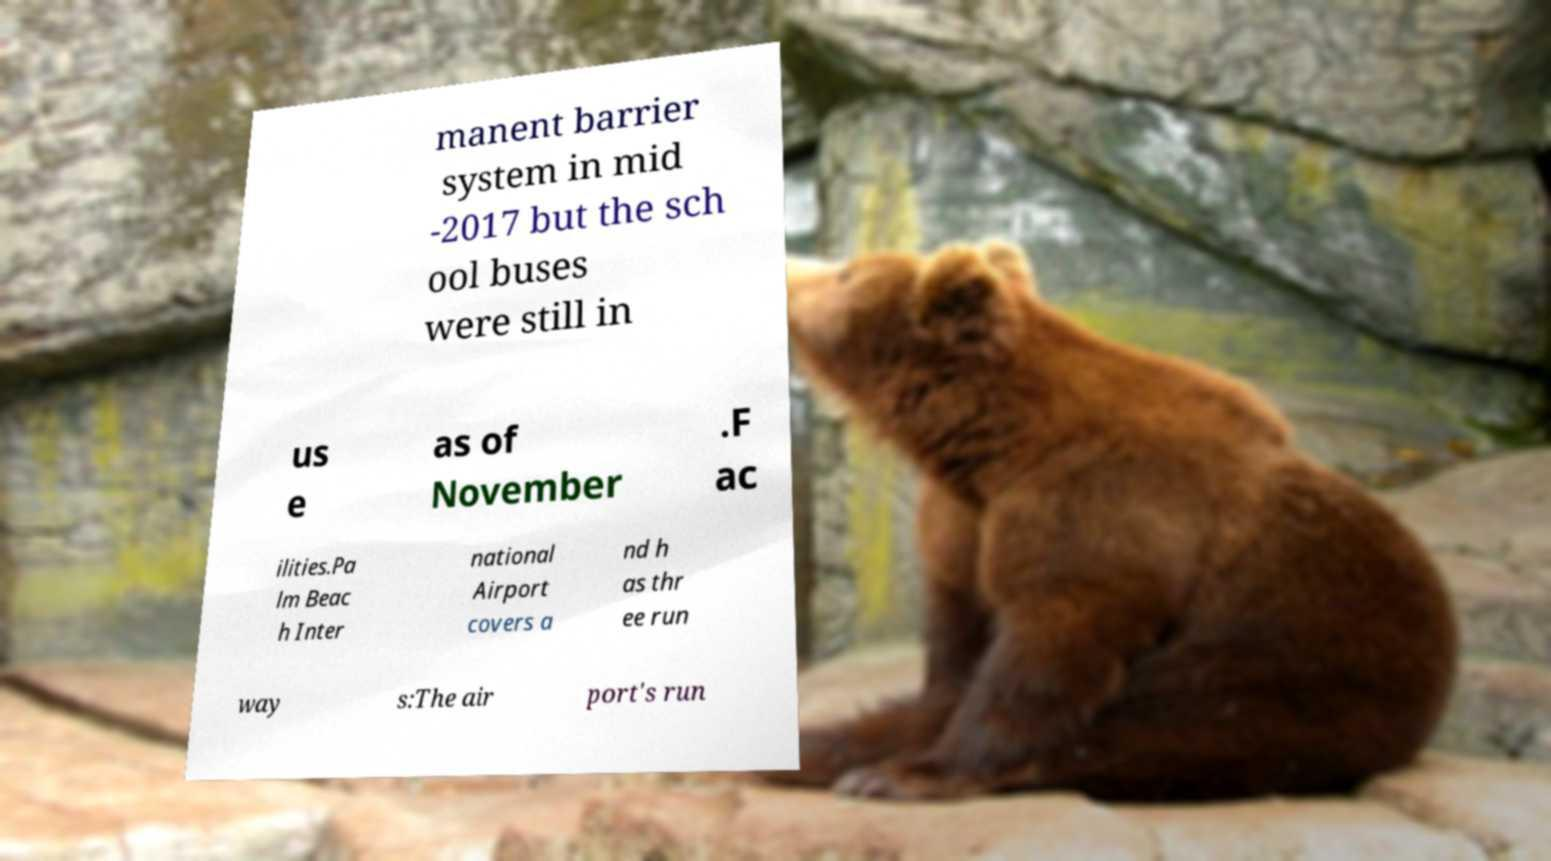Please identify and transcribe the text found in this image. manent barrier system in mid -2017 but the sch ool buses were still in us e as of November .F ac ilities.Pa lm Beac h Inter national Airport covers a nd h as thr ee run way s:The air port's run 